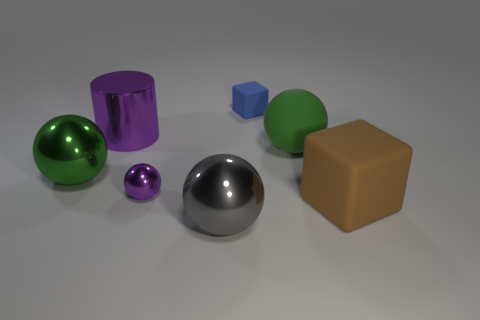What might be the purpose of this collection of objects? This collection of objects could be a part of a visual or material study, possibly for educational purposes, rendering or shading training, or for an artistic composition exploring form and color. 